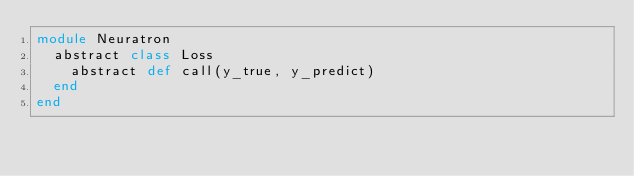<code> <loc_0><loc_0><loc_500><loc_500><_Crystal_>module Neuratron
  abstract class Loss
    abstract def call(y_true, y_predict)
  end
end
</code> 